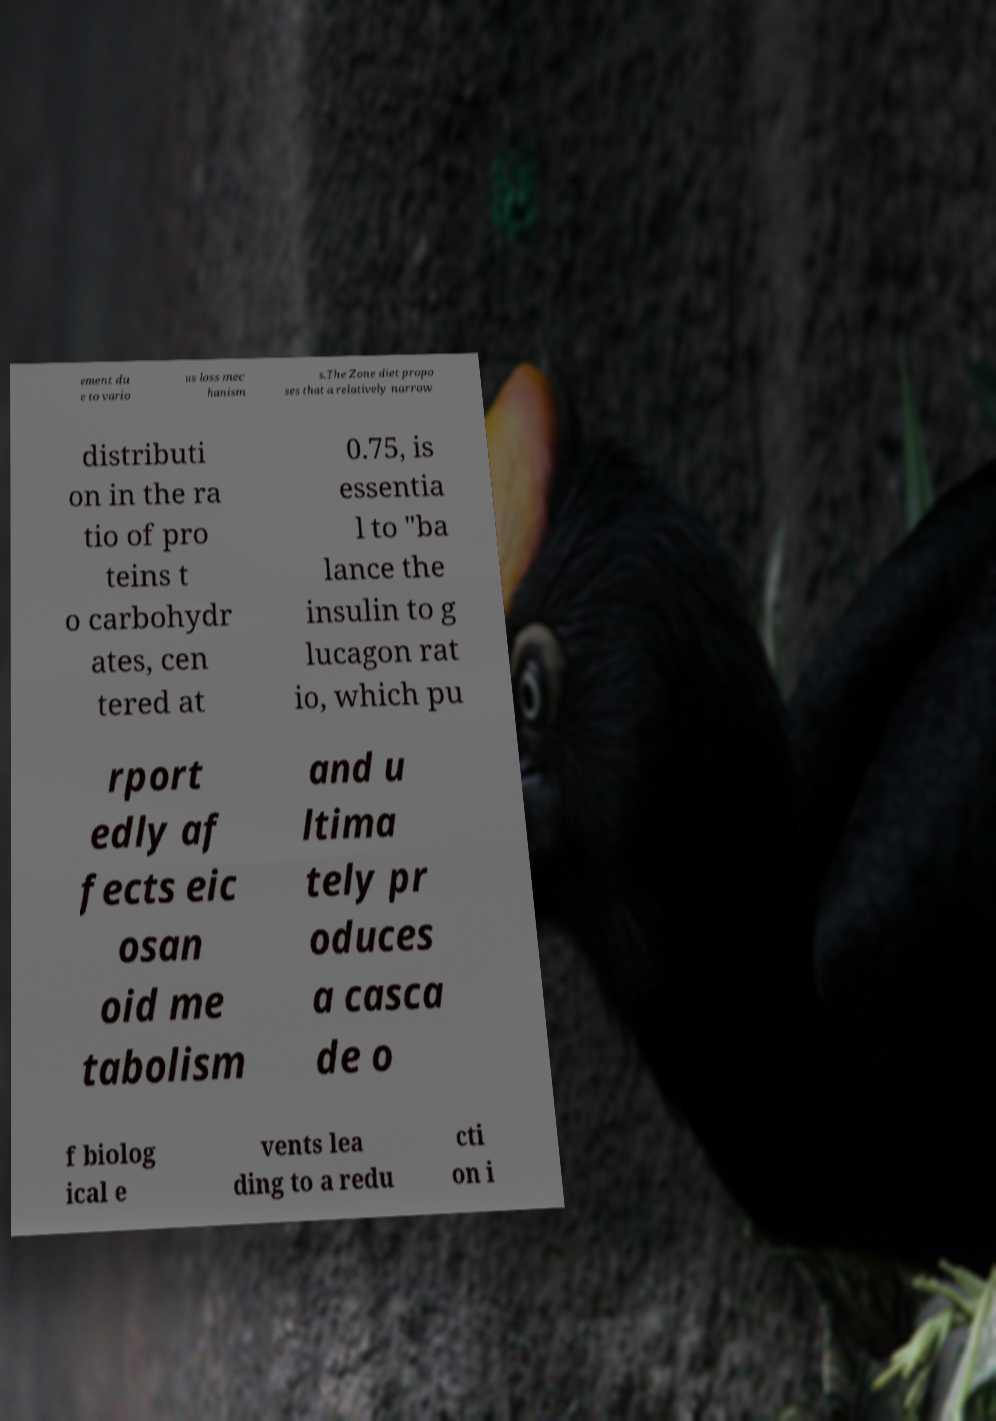Could you assist in decoding the text presented in this image and type it out clearly? ement du e to vario us loss mec hanism s.The Zone diet propo ses that a relatively narrow distributi on in the ra tio of pro teins t o carbohydr ates, cen tered at 0.75, is essentia l to "ba lance the insulin to g lucagon rat io, which pu rport edly af fects eic osan oid me tabolism and u ltima tely pr oduces a casca de o f biolog ical e vents lea ding to a redu cti on i 